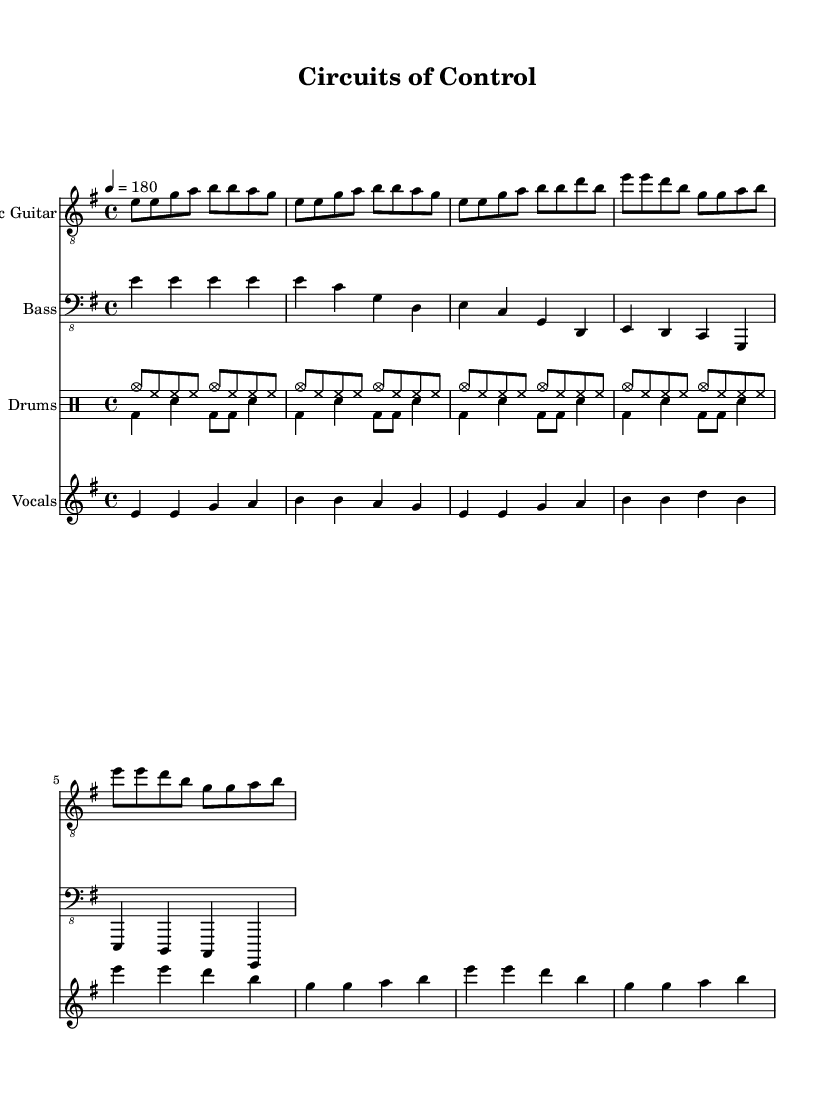What is the key signature of this music? The key signature is E minor, which is indicated by one sharp (F#). It's determined by the signature at the beginning of the score, showing that E minor is the relative minor of G major.
Answer: E minor What is the time signature of this piece? The time signature is 4/4, which is indicated at the beginning of the score. This tells us that there are four beats in each measure, and the quarter note gets one beat.
Answer: 4/4 What is the tempo marking for the piece? The tempo marking is 180 beats per minute, shown at the beginning of the score with the indication "4 = 180." This means one quarter note equals 180 beats per minute.
Answer: 180 How many measures are in the chorus section? The chorus section consists of four measures, as evidenced by the notation during that part of the score. Counting the individual measures, we see there are four distinct groupings.
Answer: 4 What instruments are featured in this composition? The instruments featured are electric guitar, bass, drums, and vocals, as listed in the score. Each instrument is represented by its own staff, showing that they are all integral to the performance of the piece.
Answer: Electric guitar, bass, drums, vocals What lyrical theme is explored in this track? The lyrical theme addresses the critique of automation in society and the resulting loss of human control. The lyrics specifically mention "binary chains" and "automated world," reflecting a punk ideology against mechanization.
Answer: Critique of automation and loss of control What type of beat characterizes the drumming in this track? The drumming features a basic punk beat, which is indicated in the drumming notation within the score. This style typically emphasizes energy and straightforward rhythms, matching the punk genre's characteristics.
Answer: Basic punk beat 